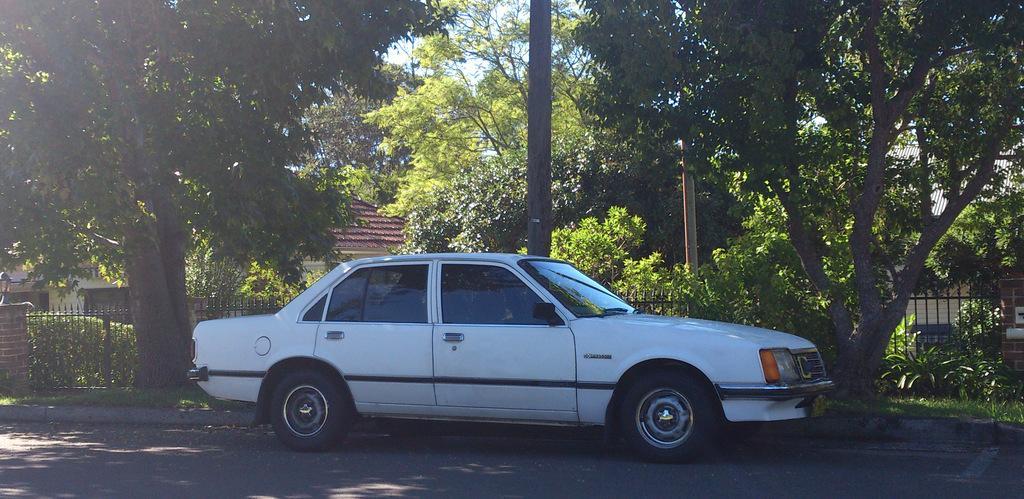How would you summarize this image in a sentence or two? In this picture we can see the white car is parked on the road side. Behind there is a black railing grill and some trees. 